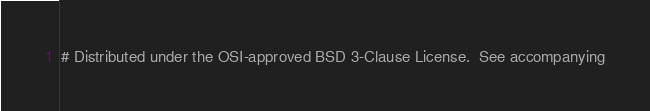Convert code to text. <code><loc_0><loc_0><loc_500><loc_500><_CMake_># Distributed under the OSI-approved BSD 3-Clause License.  See accompanying</code> 